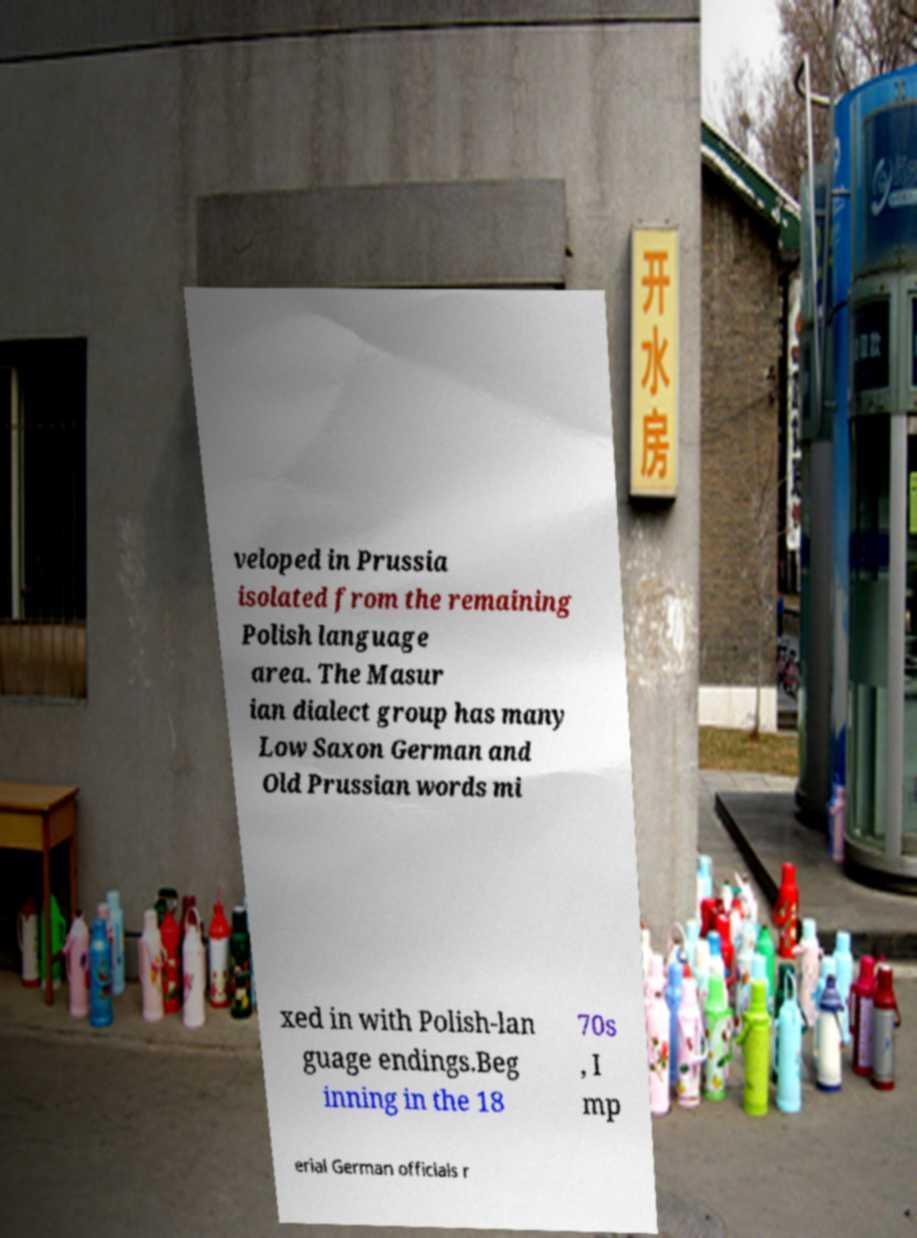Could you extract and type out the text from this image? veloped in Prussia isolated from the remaining Polish language area. The Masur ian dialect group has many Low Saxon German and Old Prussian words mi xed in with Polish-lan guage endings.Beg inning in the 18 70s , I mp erial German officials r 